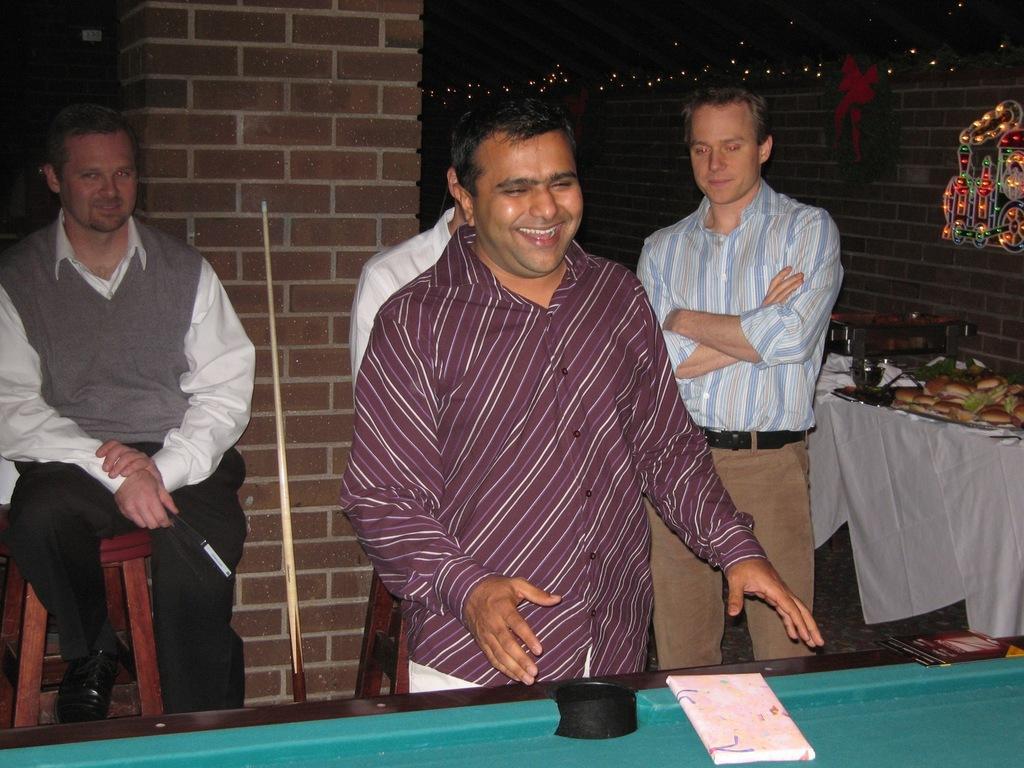Could you give a brief overview of what you see in this image? this picture shows a group of people standing and a man seated on the chair and we see some food on the table 